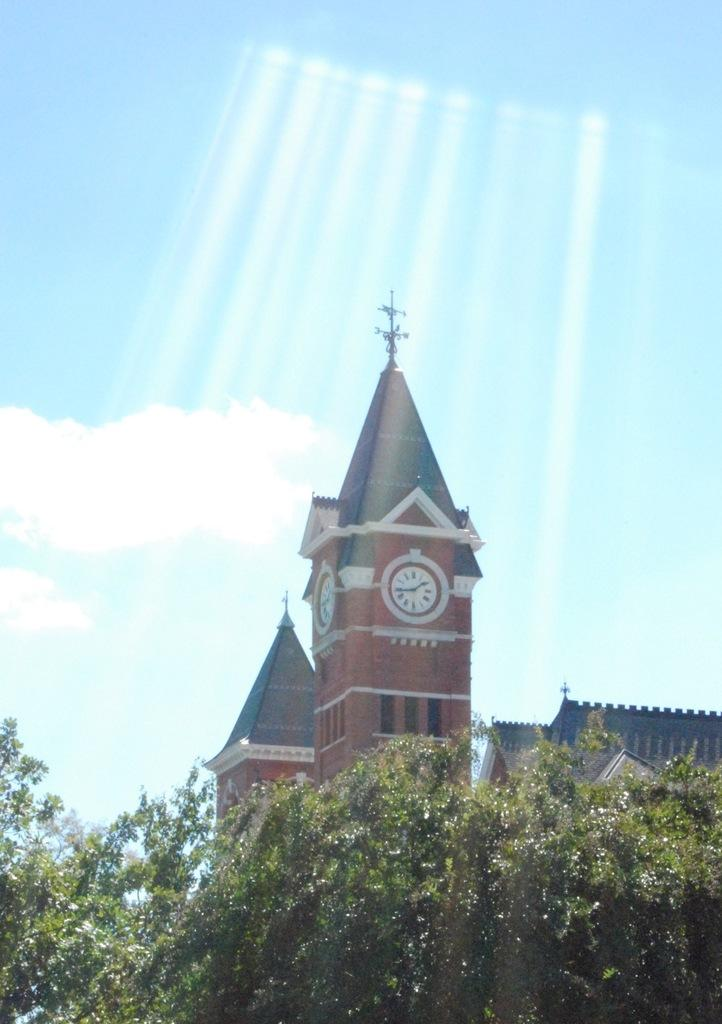What type of structures can be seen in the image? There are buildings in the image. Can you identify any specific features of one of the buildings? Yes, there is a building with a clock in the image. What is located in front of the building with the clock? There are trees in front of the building. What can be seen in the background of the image? The sky is visible in the background of the image. What is the condition of the sky in the image? Clouds are present in the sky. What type of arithmetic problem is being solved on the floor in the image? There is no arithmetic problem or floor visible in the image. How many cakes are being served on the table in the image? There is no table or cakes present in the image. 